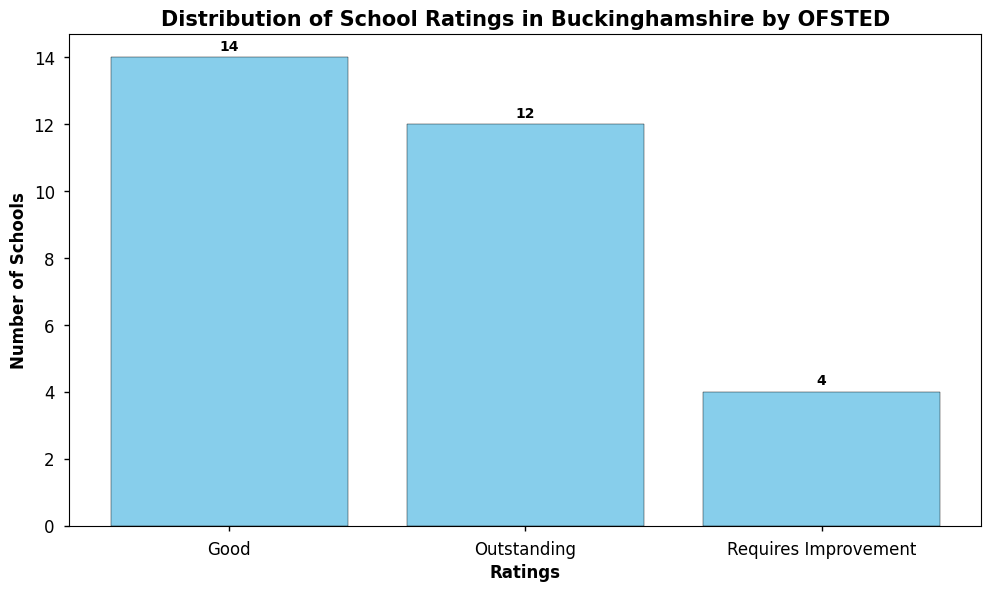What is the total number of schools that are rated as Outstanding? To find the total number of schools rated as Outstanding, look at the height of the bar labeled 'Outstanding', which represents the count of such schools.
Answer: 11 Which rating category has the highest number of schools? Compare the heights of all the bars to identify the tallest one, which represents the rating category with the highest number of schools.
Answer: Good How many more schools are rated as Requires Improvement compared to Outstanding? Count the number of schools in both categories by referring to the heights of the respective bars. Subtract the number of schools rated Outstanding from those rated Requires Improvement.
Answer: -8 What is the combined number of schools rated as Good and Outstanding? Add the heights of the bars representing the number of schools rated as Good and Outstanding.
Answer: 22 Are there any schools rated as Inadequate? Look for a bar labeled 'Inadequate'. If there is no such bar, then there are no schools with that rating.
Answer: No How does the number of schools rated as Requires Improvement compare to those rated as Good? Compare the heights of the bars representing Requires Improvement and Good ratings. Determine which one is taller and by how much.
Answer: Less by 9 What rating has the smallest number of schools? Identify the shortest bar in the histogram, which represents the rating category with the smallest number of schools.
Answer: Requires Improvement If schools rated as Outstanding receive extra funding, how many schools would this funding impact? Count the number of schools rated as Outstanding by looking at the height of the respective bar.
Answer: 11 What is the difference between the number of schools rated as Good and those rated as Outstanding? Subtract the number of schools rated Outstanding from those rated Good by comparing the heights of their respective bars.
Answer: 2 What proportion of schools in the histogram are rated as Requires Improvement? Divide the number of schools rated Requires Improvement by the total number of schools, then multiply by 100 to get the percentage.
Answer: 10% 